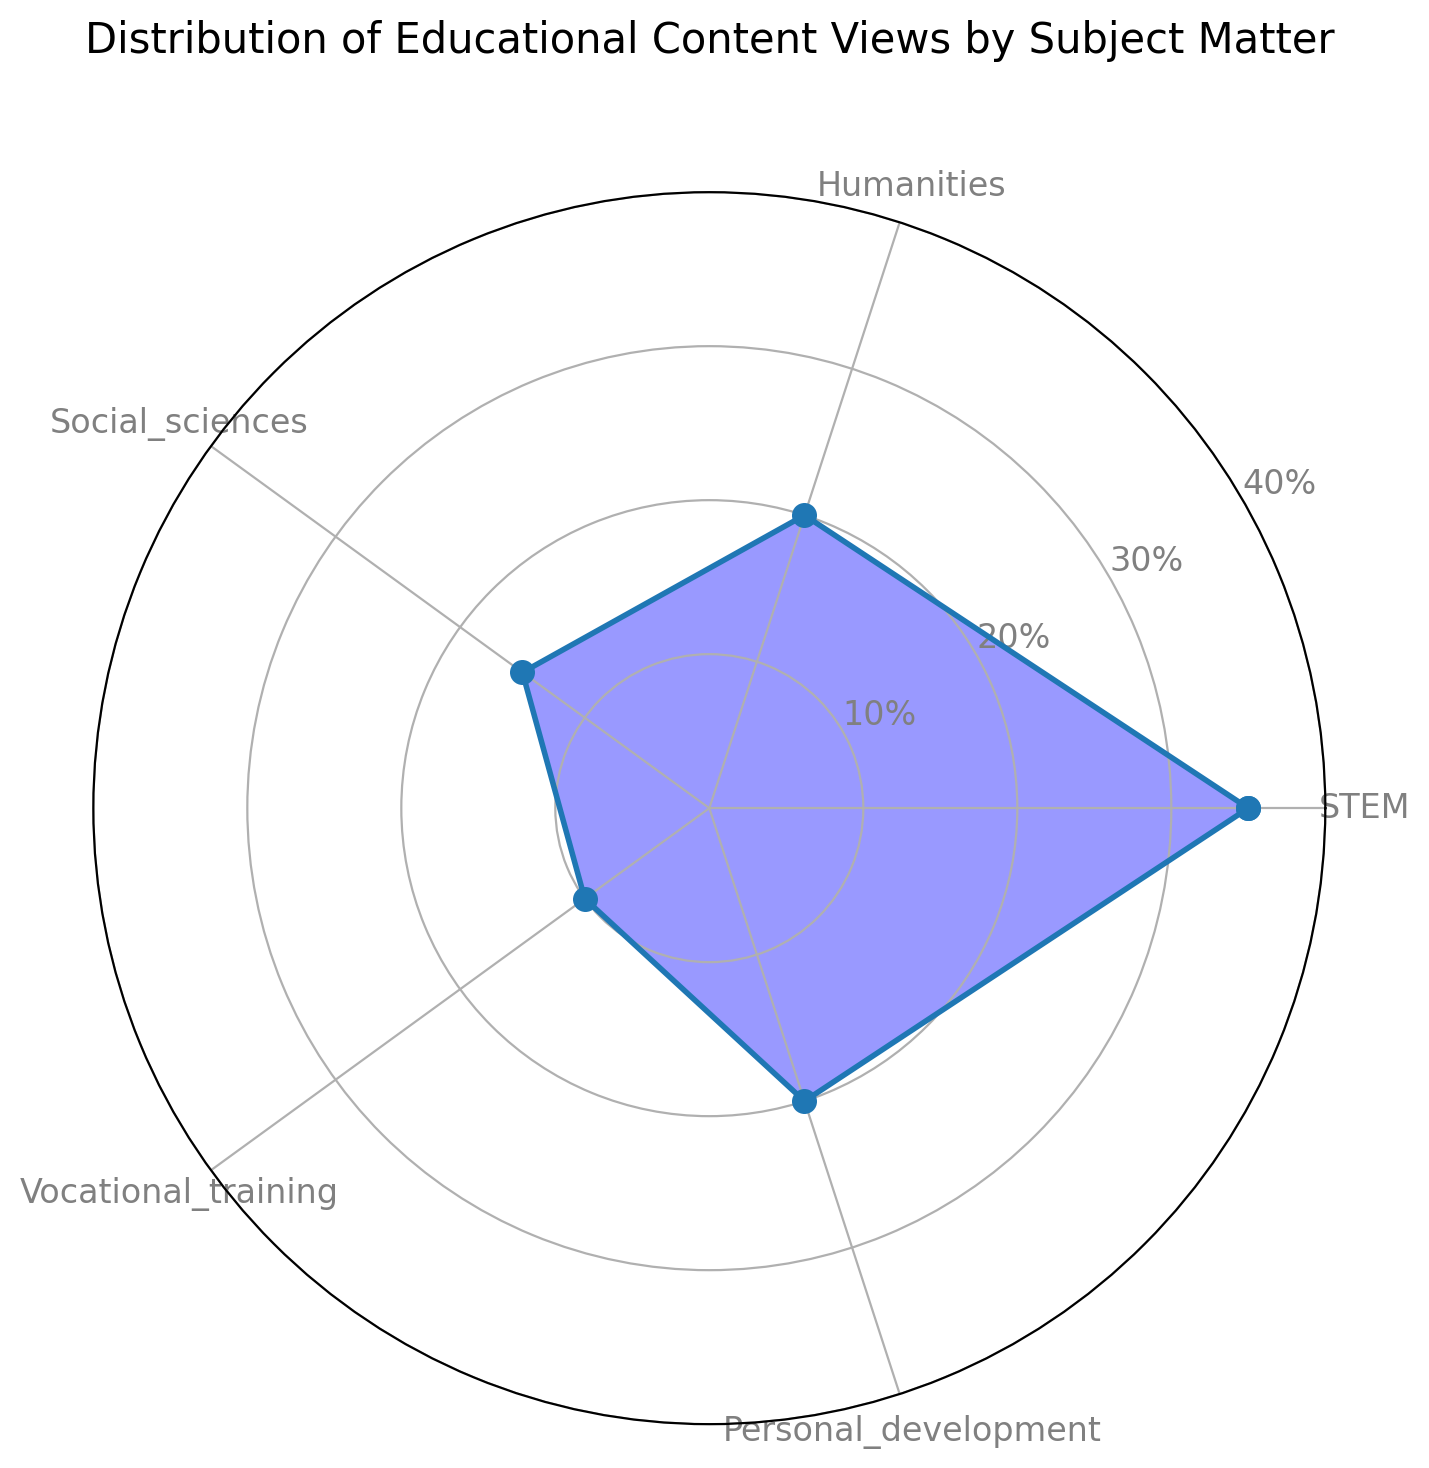Which subject has the highest percentage of views? The highest percentage of views is shown by the largest segment in the rose chart. The segment labeled "STEM" extends the furthest, indicating 35% of views.
Answer: STEM Which two subjects have an equal percentage of views? The rose chart shows that the segments for "Humanities" and "Personal Development" extend to the same radius, both reaching 20%.
Answer: Humanities and Personal Development How much more percentage of views does STEM have compared to Social Sciences? The segment for "STEM" extends to 35%, and "Social Sciences" extends to 15%. The difference between the two is 35% - 15% = 20%.
Answer: 20% What are the subjects with the smallest and second smallest percentages of views? The smallest segment belongs to "Vocational Training" at 10%. The next smallest segment belongs to "Social Sciences" at 15%.
Answer: Vocational Training and Social Sciences What is the total percentage of views accounted for by Personal Development and Humanities? The percentages for "Personal Development" and "Humanities" are both 20%. Adding these gives 20% + 20% = 40%.
Answer: 40% What is the average percentage of views across all subjects? The total percentage is the sum of all individual percentages: 35% (STEM) + 20% (Humanities) + 15% (Social Sciences) + 10% (Vocational Training) + 20% (Personal Development) = 100%. The average is 100% / 5 = 20%.
Answer: 20% Which subject's segment is visually closest to the half-way point on the radial chart? The half-way point on the radial chart is 20%. Both "Humanities" and "Personal Development" have segments that extend exactly to 20%.
Answer: Humanities and Personal Development What is the difference in the sum of views between the top two subjects and the remaining subjects? The top two subjects by percent of views are "STEM" and "Humanities" with 35% and 20% respectively, totaling 55%. The remaining subjects are "Social Sciences" (15%), "Vocational Training" (10%), and "Personal Development" (20%), totaling 45%. The difference is 55% - 45% = 10%.
Answer: 10% 